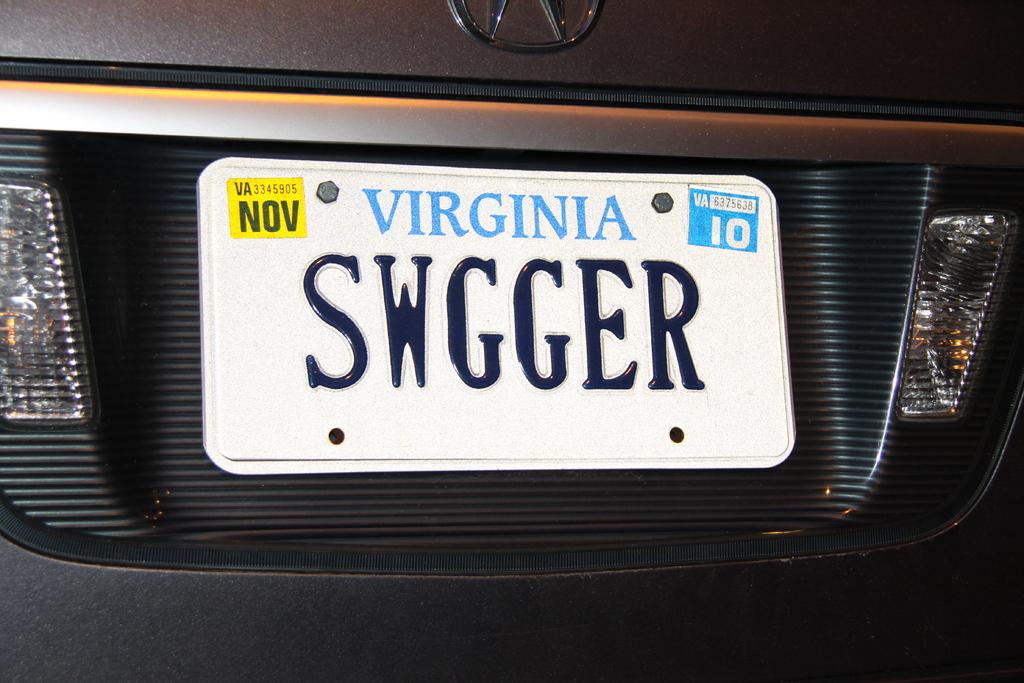What is the plate id?
Your answer should be compact. Swgger. 